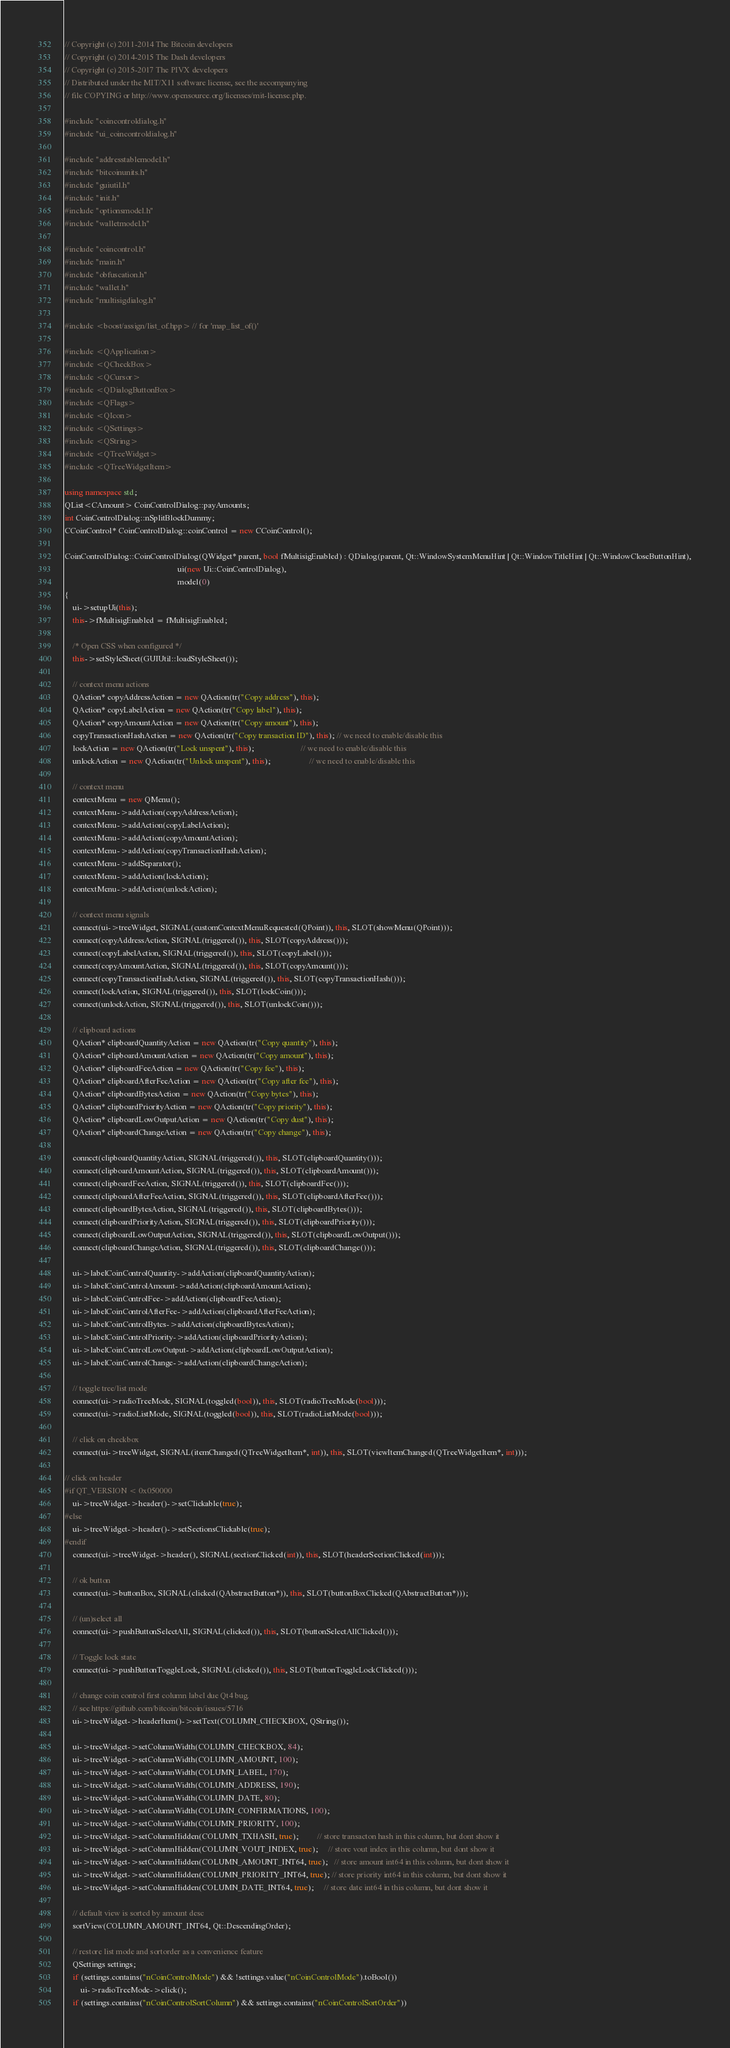<code> <loc_0><loc_0><loc_500><loc_500><_C++_>// Copyright (c) 2011-2014 The Bitcoin developers
// Copyright (c) 2014-2015 The Dash developers
// Copyright (c) 2015-2017 The PIVX developers
// Distributed under the MIT/X11 software license, see the accompanying
// file COPYING or http://www.opensource.org/licenses/mit-license.php.

#include "coincontroldialog.h"
#include "ui_coincontroldialog.h"

#include "addresstablemodel.h"
#include "bitcoinunits.h"
#include "guiutil.h"
#include "init.h"
#include "optionsmodel.h"
#include "walletmodel.h"

#include "coincontrol.h"
#include "main.h"
#include "obfuscation.h"
#include "wallet.h"
#include "multisigdialog.h"

#include <boost/assign/list_of.hpp> // for 'map_list_of()'

#include <QApplication>
#include <QCheckBox>
#include <QCursor>
#include <QDialogButtonBox>
#include <QFlags>
#include <QIcon>
#include <QSettings>
#include <QString>
#include <QTreeWidget>
#include <QTreeWidgetItem>

using namespace std;
QList<CAmount> CoinControlDialog::payAmounts;
int CoinControlDialog::nSplitBlockDummy;
CCoinControl* CoinControlDialog::coinControl = new CCoinControl();

CoinControlDialog::CoinControlDialog(QWidget* parent, bool fMultisigEnabled) : QDialog(parent, Qt::WindowSystemMenuHint | Qt::WindowTitleHint | Qt::WindowCloseButtonHint),
                                                        ui(new Ui::CoinControlDialog),
                                                        model(0)
{
    ui->setupUi(this);
    this->fMultisigEnabled = fMultisigEnabled;

    /* Open CSS when configured */
    this->setStyleSheet(GUIUtil::loadStyleSheet());

    // context menu actions
    QAction* copyAddressAction = new QAction(tr("Copy address"), this);
    QAction* copyLabelAction = new QAction(tr("Copy label"), this);
    QAction* copyAmountAction = new QAction(tr("Copy amount"), this);
    copyTransactionHashAction = new QAction(tr("Copy transaction ID"), this); // we need to enable/disable this
    lockAction = new QAction(tr("Lock unspent"), this);                       // we need to enable/disable this
    unlockAction = new QAction(tr("Unlock unspent"), this);                   // we need to enable/disable this

    // context menu
    contextMenu = new QMenu();
    contextMenu->addAction(copyAddressAction);
    contextMenu->addAction(copyLabelAction);
    contextMenu->addAction(copyAmountAction);
    contextMenu->addAction(copyTransactionHashAction);
    contextMenu->addSeparator();
    contextMenu->addAction(lockAction);
    contextMenu->addAction(unlockAction);

    // context menu signals
    connect(ui->treeWidget, SIGNAL(customContextMenuRequested(QPoint)), this, SLOT(showMenu(QPoint)));
    connect(copyAddressAction, SIGNAL(triggered()), this, SLOT(copyAddress()));
    connect(copyLabelAction, SIGNAL(triggered()), this, SLOT(copyLabel()));
    connect(copyAmountAction, SIGNAL(triggered()), this, SLOT(copyAmount()));
    connect(copyTransactionHashAction, SIGNAL(triggered()), this, SLOT(copyTransactionHash()));
    connect(lockAction, SIGNAL(triggered()), this, SLOT(lockCoin()));
    connect(unlockAction, SIGNAL(triggered()), this, SLOT(unlockCoin()));

    // clipboard actions
    QAction* clipboardQuantityAction = new QAction(tr("Copy quantity"), this);
    QAction* clipboardAmountAction = new QAction(tr("Copy amount"), this);
    QAction* clipboardFeeAction = new QAction(tr("Copy fee"), this);
    QAction* clipboardAfterFeeAction = new QAction(tr("Copy after fee"), this);
    QAction* clipboardBytesAction = new QAction(tr("Copy bytes"), this);
    QAction* clipboardPriorityAction = new QAction(tr("Copy priority"), this);
    QAction* clipboardLowOutputAction = new QAction(tr("Copy dust"), this);
    QAction* clipboardChangeAction = new QAction(tr("Copy change"), this);

    connect(clipboardQuantityAction, SIGNAL(triggered()), this, SLOT(clipboardQuantity()));
    connect(clipboardAmountAction, SIGNAL(triggered()), this, SLOT(clipboardAmount()));
    connect(clipboardFeeAction, SIGNAL(triggered()), this, SLOT(clipboardFee()));
    connect(clipboardAfterFeeAction, SIGNAL(triggered()), this, SLOT(clipboardAfterFee()));
    connect(clipboardBytesAction, SIGNAL(triggered()), this, SLOT(clipboardBytes()));
    connect(clipboardPriorityAction, SIGNAL(triggered()), this, SLOT(clipboardPriority()));
    connect(clipboardLowOutputAction, SIGNAL(triggered()), this, SLOT(clipboardLowOutput()));
    connect(clipboardChangeAction, SIGNAL(triggered()), this, SLOT(clipboardChange()));

    ui->labelCoinControlQuantity->addAction(clipboardQuantityAction);
    ui->labelCoinControlAmount->addAction(clipboardAmountAction);
    ui->labelCoinControlFee->addAction(clipboardFeeAction);
    ui->labelCoinControlAfterFee->addAction(clipboardAfterFeeAction);
    ui->labelCoinControlBytes->addAction(clipboardBytesAction);
    ui->labelCoinControlPriority->addAction(clipboardPriorityAction);
    ui->labelCoinControlLowOutput->addAction(clipboardLowOutputAction);
    ui->labelCoinControlChange->addAction(clipboardChangeAction);

    // toggle tree/list mode
    connect(ui->radioTreeMode, SIGNAL(toggled(bool)), this, SLOT(radioTreeMode(bool)));
    connect(ui->radioListMode, SIGNAL(toggled(bool)), this, SLOT(radioListMode(bool)));

    // click on checkbox
    connect(ui->treeWidget, SIGNAL(itemChanged(QTreeWidgetItem*, int)), this, SLOT(viewItemChanged(QTreeWidgetItem*, int)));

// click on header
#if QT_VERSION < 0x050000
    ui->treeWidget->header()->setClickable(true);
#else
    ui->treeWidget->header()->setSectionsClickable(true);
#endif
    connect(ui->treeWidget->header(), SIGNAL(sectionClicked(int)), this, SLOT(headerSectionClicked(int)));

    // ok button
    connect(ui->buttonBox, SIGNAL(clicked(QAbstractButton*)), this, SLOT(buttonBoxClicked(QAbstractButton*)));

    // (un)select all
    connect(ui->pushButtonSelectAll, SIGNAL(clicked()), this, SLOT(buttonSelectAllClicked()));

    // Toggle lock state
    connect(ui->pushButtonToggleLock, SIGNAL(clicked()), this, SLOT(buttonToggleLockClicked()));

    // change coin control first column label due Qt4 bug.
    // see https://github.com/bitcoin/bitcoin/issues/5716
    ui->treeWidget->headerItem()->setText(COLUMN_CHECKBOX, QString());

    ui->treeWidget->setColumnWidth(COLUMN_CHECKBOX, 84);
    ui->treeWidget->setColumnWidth(COLUMN_AMOUNT, 100);
    ui->treeWidget->setColumnWidth(COLUMN_LABEL, 170);
    ui->treeWidget->setColumnWidth(COLUMN_ADDRESS, 190);
    ui->treeWidget->setColumnWidth(COLUMN_DATE, 80);
    ui->treeWidget->setColumnWidth(COLUMN_CONFIRMATIONS, 100);
    ui->treeWidget->setColumnWidth(COLUMN_PRIORITY, 100);
    ui->treeWidget->setColumnHidden(COLUMN_TXHASH, true);         // store transacton hash in this column, but dont show it
    ui->treeWidget->setColumnHidden(COLUMN_VOUT_INDEX, true);     // store vout index in this column, but dont show it
    ui->treeWidget->setColumnHidden(COLUMN_AMOUNT_INT64, true);   // store amount int64 in this column, but dont show it
    ui->treeWidget->setColumnHidden(COLUMN_PRIORITY_INT64, true); // store priority int64 in this column, but dont show it
    ui->treeWidget->setColumnHidden(COLUMN_DATE_INT64, true);     // store date int64 in this column, but dont show it

    // default view is sorted by amount desc
    sortView(COLUMN_AMOUNT_INT64, Qt::DescendingOrder);

    // restore list mode and sortorder as a convenience feature
    QSettings settings;
    if (settings.contains("nCoinControlMode") && !settings.value("nCoinControlMode").toBool())
        ui->radioTreeMode->click();
    if (settings.contains("nCoinControlSortColumn") && settings.contains("nCoinControlSortOrder"))</code> 